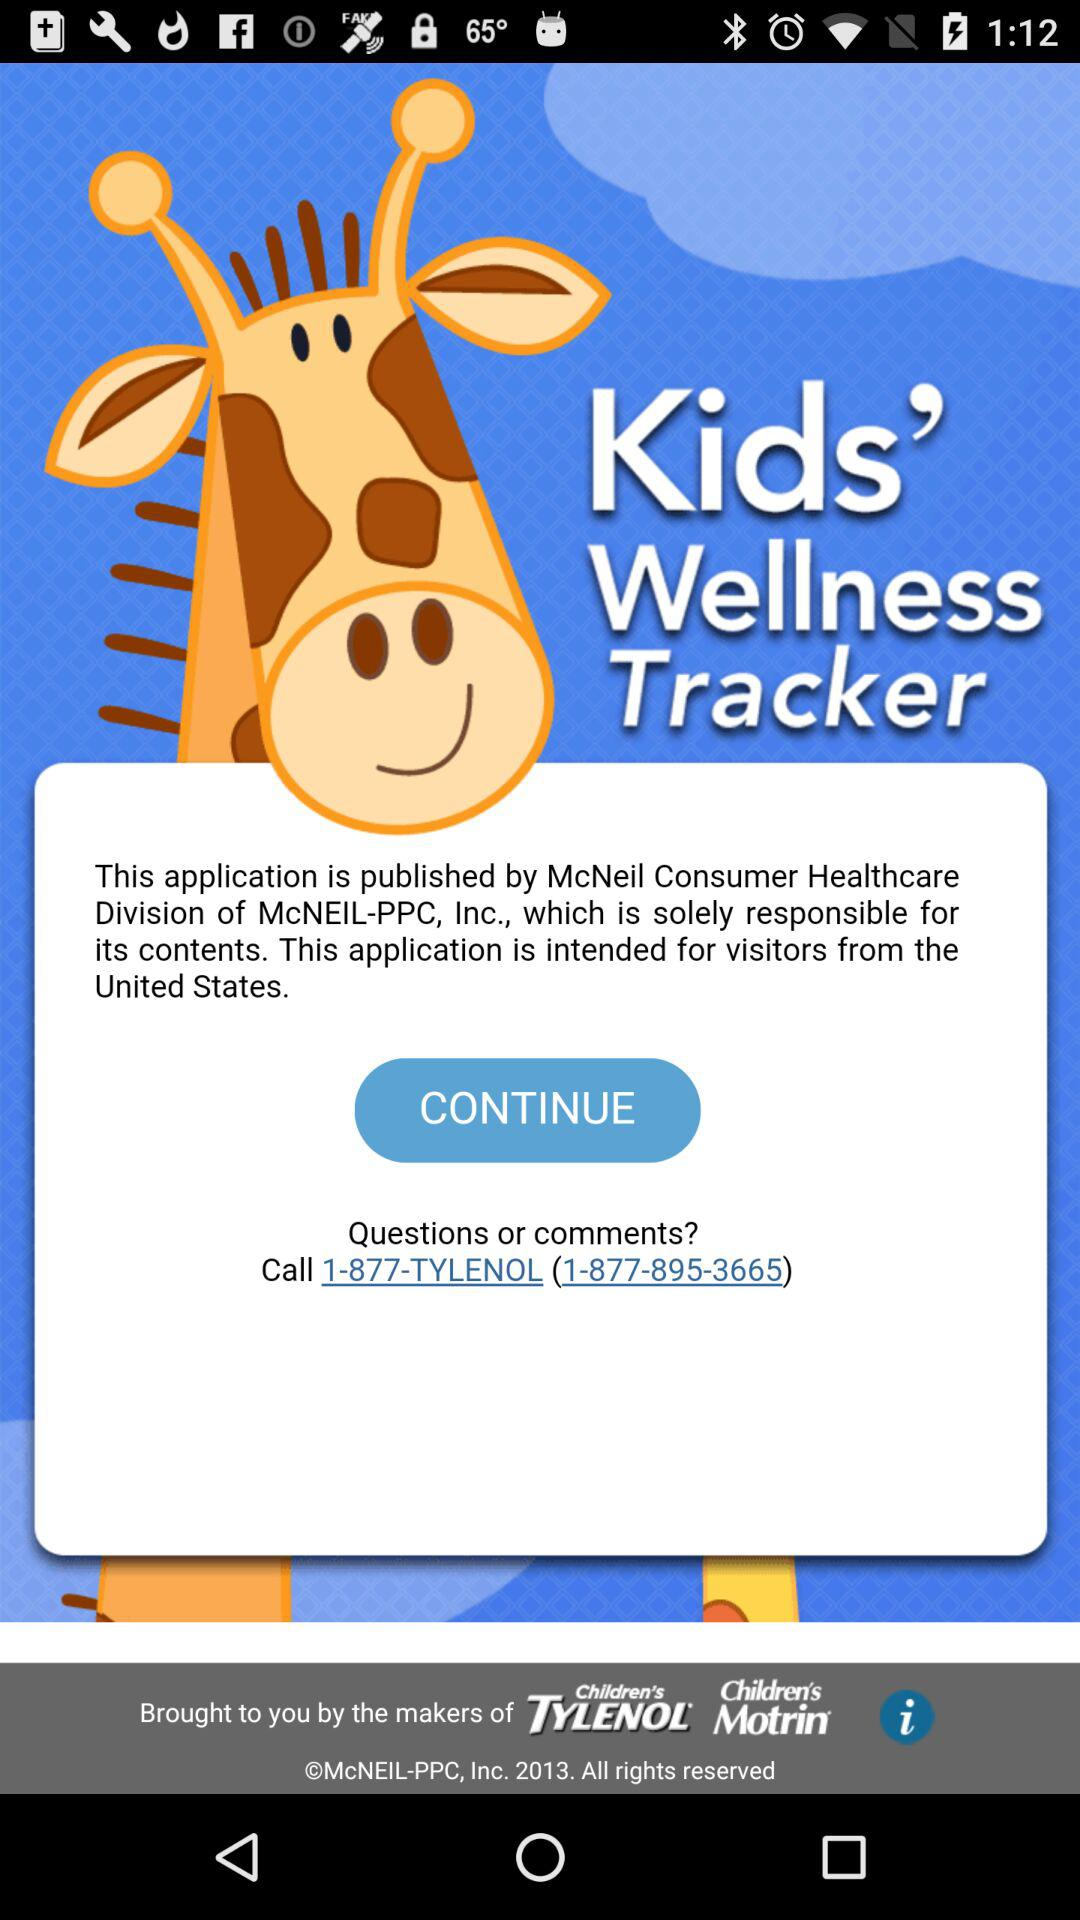What is the contact number for any questions? The contact number is 1-877-895-3665. 